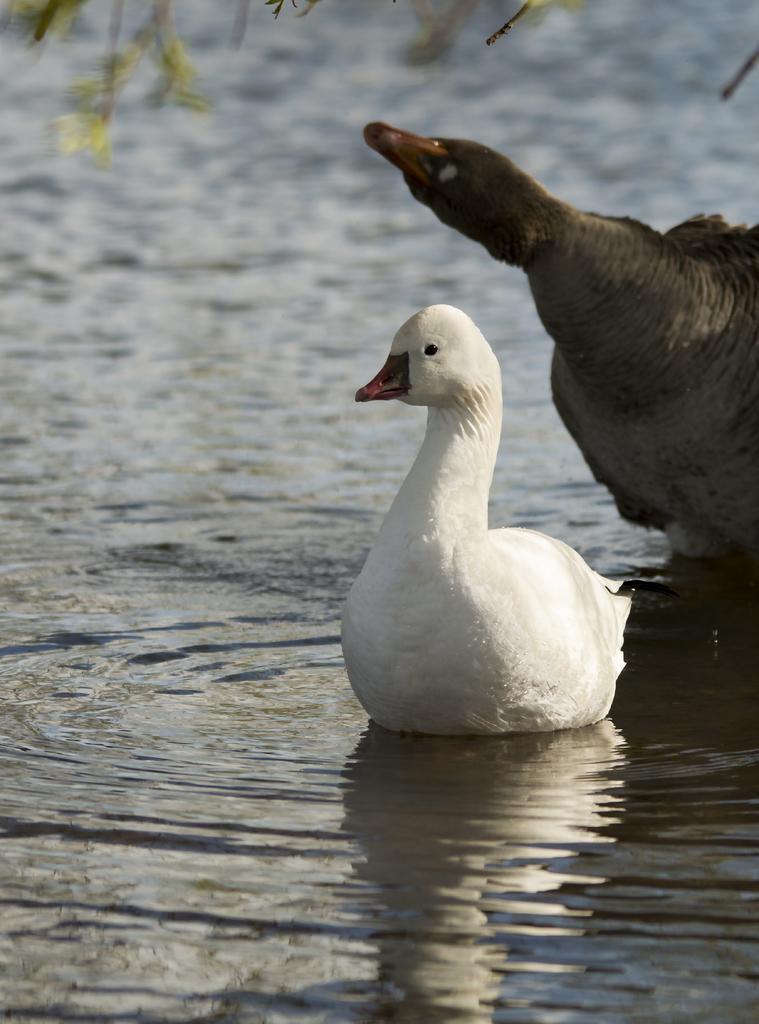How would you summarize this image in a sentence or two? In this image we can see birds on the water. At the top we can see branches. 